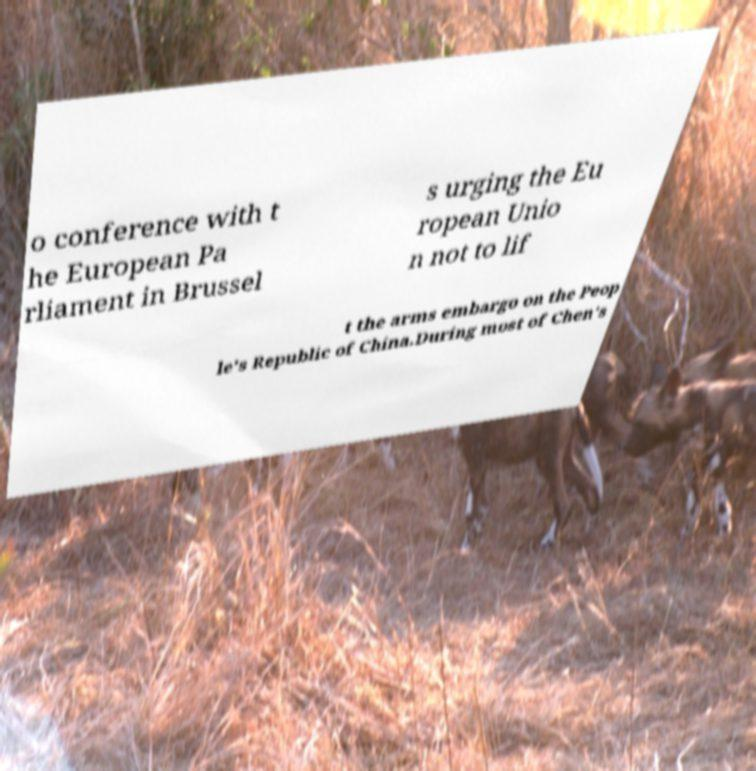I need the written content from this picture converted into text. Can you do that? o conference with t he European Pa rliament in Brussel s urging the Eu ropean Unio n not to lif t the arms embargo on the Peop le's Republic of China.During most of Chen's 